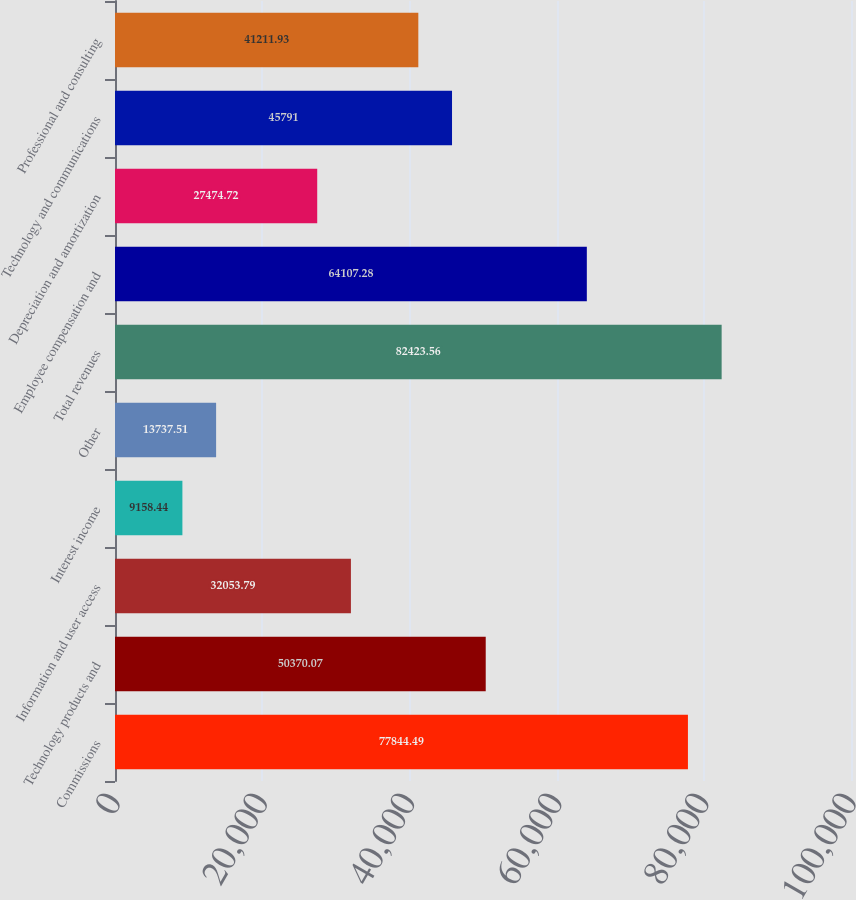Convert chart. <chart><loc_0><loc_0><loc_500><loc_500><bar_chart><fcel>Commissions<fcel>Technology products and<fcel>Information and user access<fcel>Interest income<fcel>Other<fcel>Total revenues<fcel>Employee compensation and<fcel>Depreciation and amortization<fcel>Technology and communications<fcel>Professional and consulting<nl><fcel>77844.5<fcel>50370.1<fcel>32053.8<fcel>9158.44<fcel>13737.5<fcel>82423.6<fcel>64107.3<fcel>27474.7<fcel>45791<fcel>41211.9<nl></chart> 